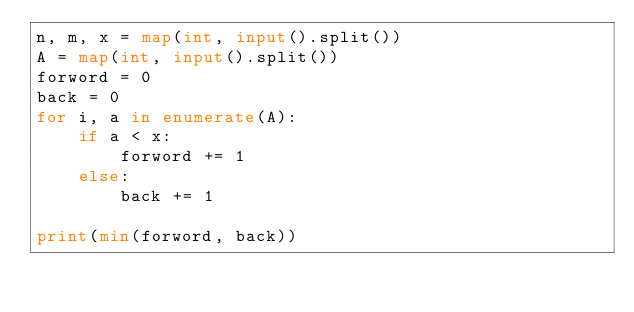Convert code to text. <code><loc_0><loc_0><loc_500><loc_500><_Python_>n, m, x = map(int, input().split())
A = map(int, input().split())
forword = 0
back = 0
for i, a in enumerate(A):
    if a < x:
        forword += 1
    else:
        back += 1

print(min(forword, back))
</code> 